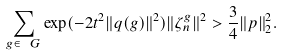<formula> <loc_0><loc_0><loc_500><loc_500>\sum _ { g \in \ G } \exp ( - 2 t ^ { 2 } \| q ( g ) \| ^ { 2 } ) \| \zeta _ { n } ^ { g } \| ^ { 2 } > \frac { 3 } { 4 } \| p \| ^ { 2 } _ { 2 } .</formula> 